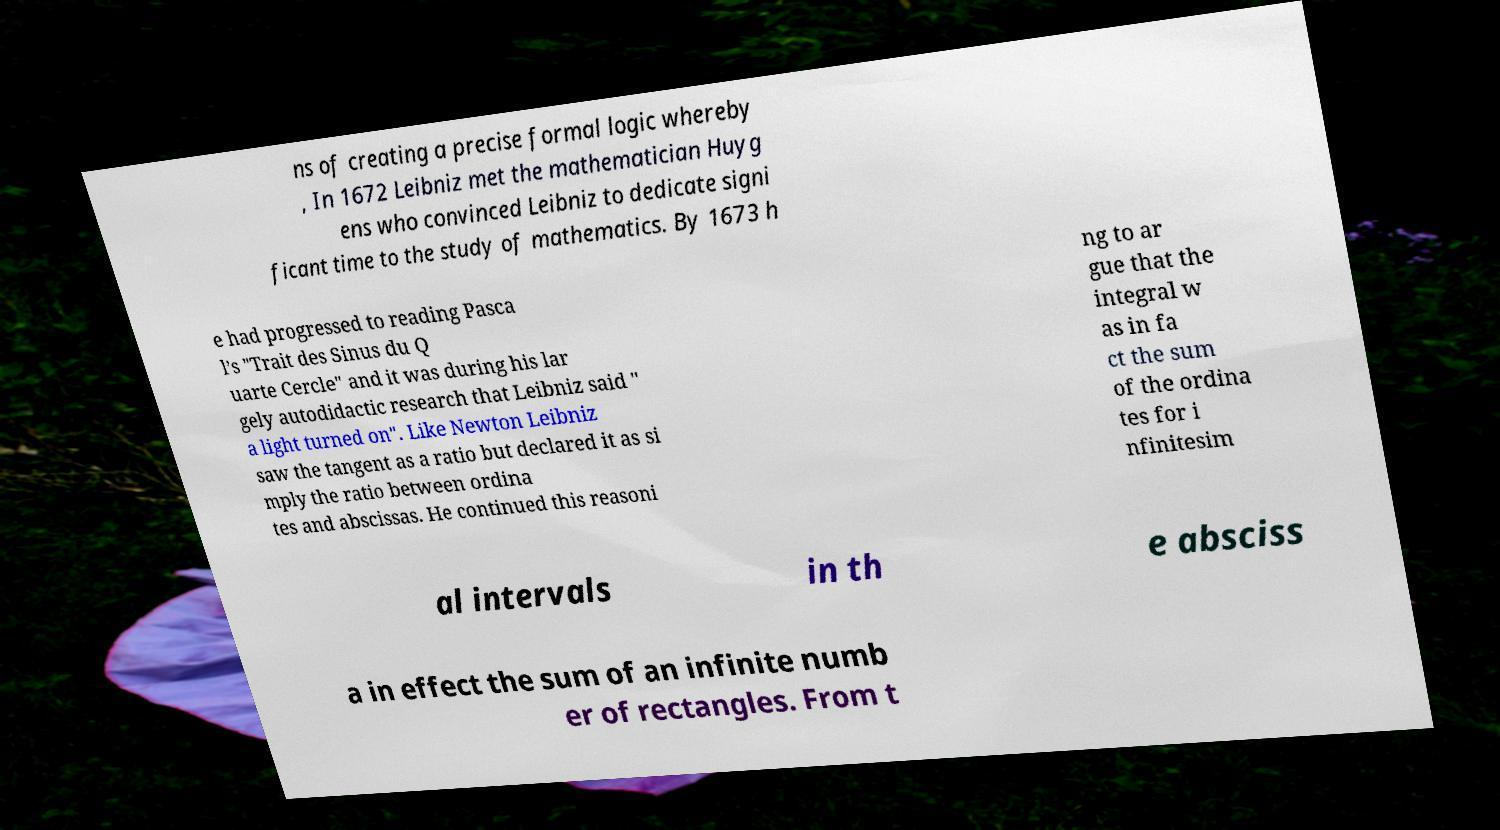What messages or text are displayed in this image? I need them in a readable, typed format. ns of creating a precise formal logic whereby , In 1672 Leibniz met the mathematician Huyg ens who convinced Leibniz to dedicate signi ficant time to the study of mathematics. By 1673 h e had progressed to reading Pasca l’s "Trait des Sinus du Q uarte Cercle" and it was during his lar gely autodidactic research that Leibniz said " a light turned on". Like Newton Leibniz saw the tangent as a ratio but declared it as si mply the ratio between ordina tes and abscissas. He continued this reasoni ng to ar gue that the integral w as in fa ct the sum of the ordina tes for i nfinitesim al intervals in th e absciss a in effect the sum of an infinite numb er of rectangles. From t 